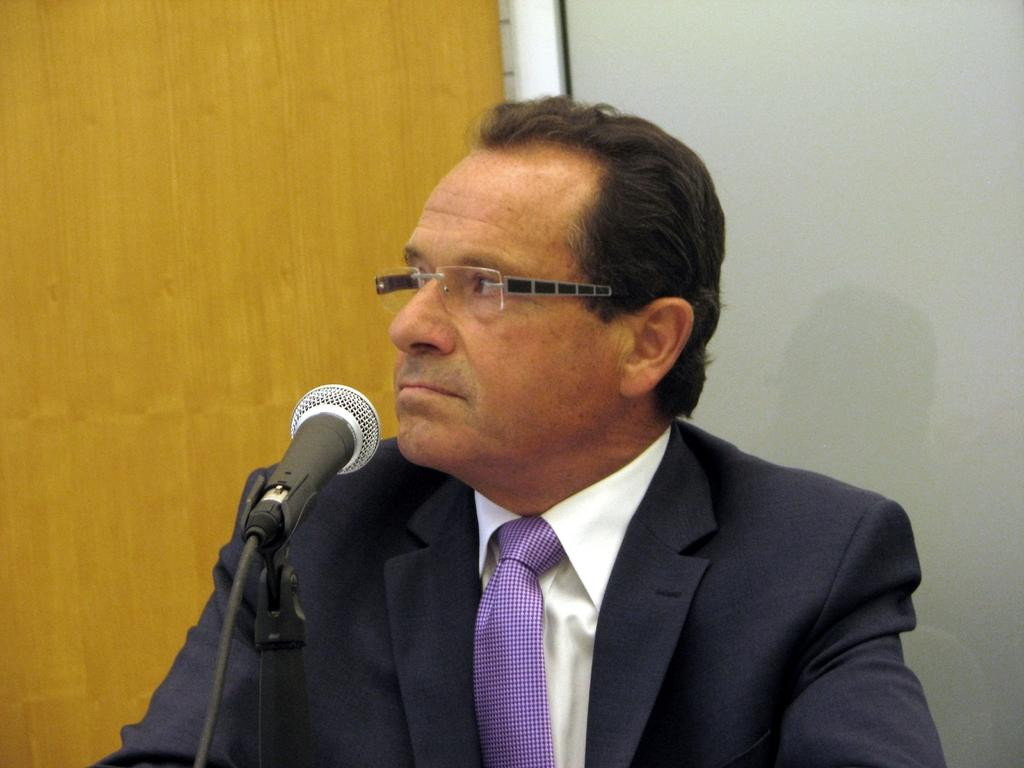Who is the person in the image? There is a man in the image. What is the man wearing? The man is wearing a suit and a tie. What object is in front of the man? There is a mic in front of the man. What can be seen in the background of the image? There is a door and a wall in the background of the image. What type of paint is the man using to solve arithmetic problems in the image? There is no paint or arithmetic problems present in the image. The man is simply standing in front of a mic, wearing a suit and tie. 